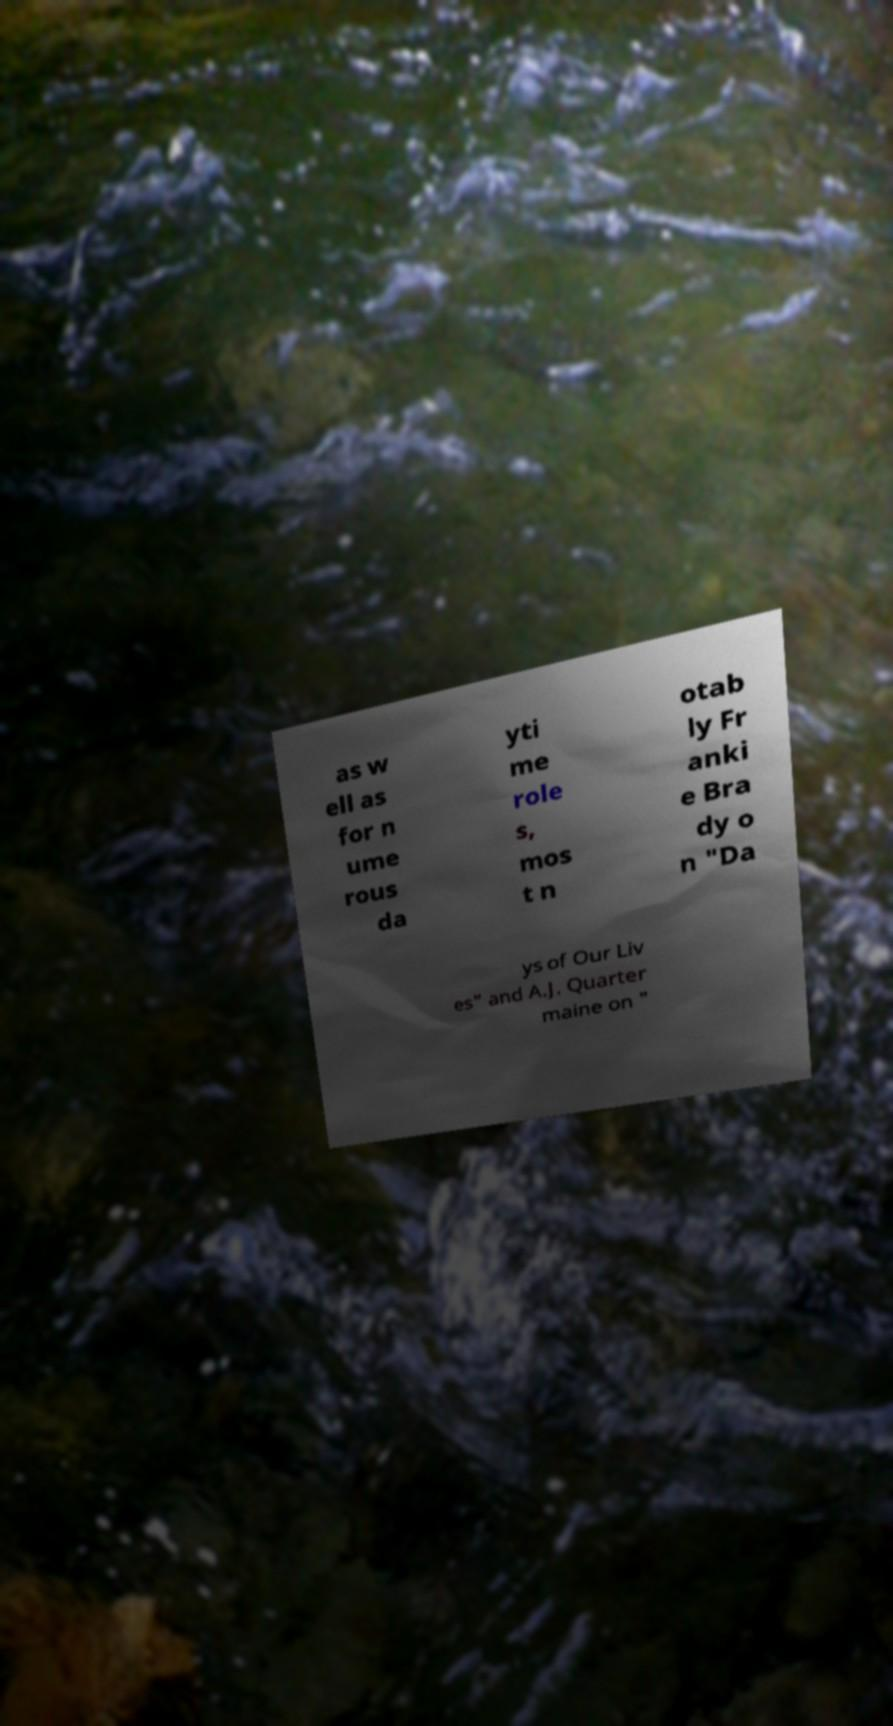What messages or text are displayed in this image? I need them in a readable, typed format. as w ell as for n ume rous da yti me role s, mos t n otab ly Fr anki e Bra dy o n "Da ys of Our Liv es" and A.J. Quarter maine on " 